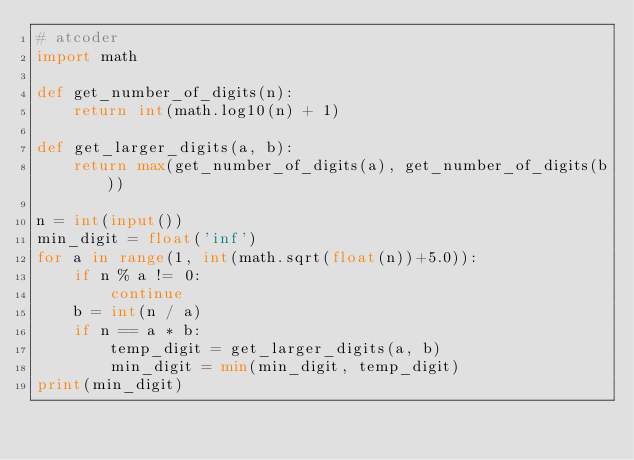Convert code to text. <code><loc_0><loc_0><loc_500><loc_500><_Python_># atcoder
import math

def get_number_of_digits(n):
    return int(math.log10(n) + 1)

def get_larger_digits(a, b):
    return max(get_number_of_digits(a), get_number_of_digits(b))

n = int(input())
min_digit = float('inf')
for a in range(1, int(math.sqrt(float(n))+5.0)):
    if n % a != 0:
        continue
    b = int(n / a)
    if n == a * b:
        temp_digit = get_larger_digits(a, b)
        min_digit = min(min_digit, temp_digit)
print(min_digit)</code> 